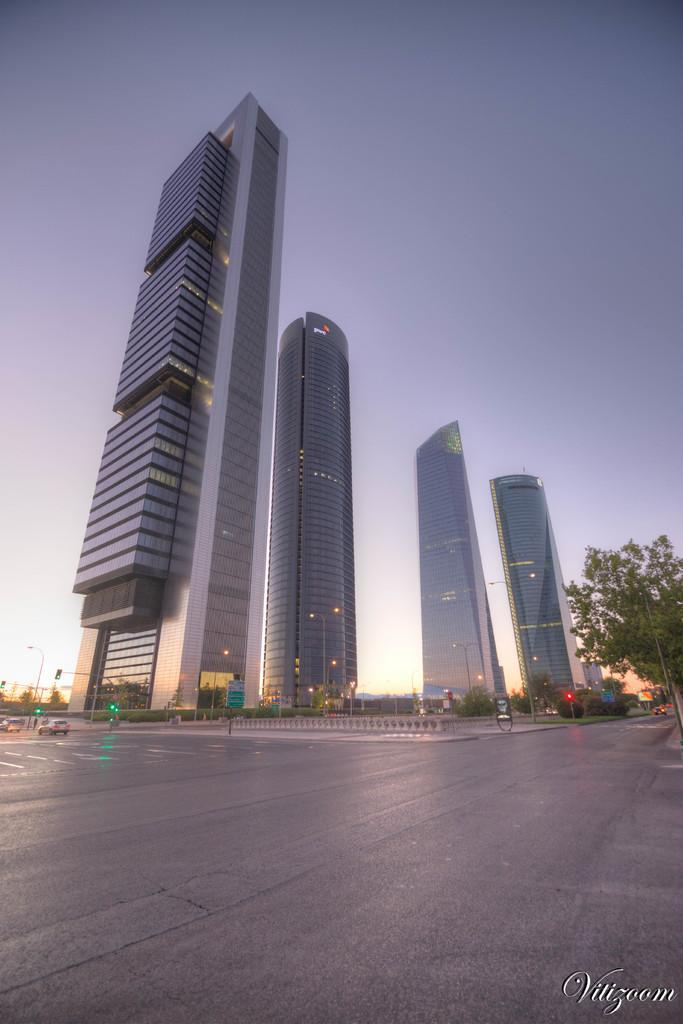What is the main feature of the image? There is a road in the image. What else can be seen in the center of the image? There are buildings at the center of the image. What type of vegetation is on the right side of the image? There is a tree on the right side of the image. What is visible in the background of the image? The sky is visible in the background of the image. What type of disease is affecting the tree on the right side of the image? There is no indication of any disease affecting the tree in the image; it appears to be a healthy tree. What request can be made to the buildings in the center of the image? There is no context for making a request to the buildings in the image, as they are just part of the scenery. 